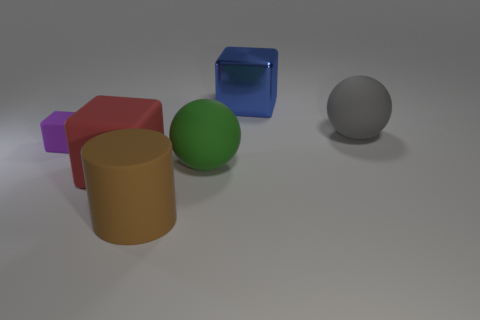Add 1 big matte cubes. How many objects exist? 7 Subtract all spheres. How many objects are left? 4 Subtract all big rubber blocks. Subtract all big green rubber balls. How many objects are left? 4 Add 5 gray things. How many gray things are left? 6 Add 4 big balls. How many big balls exist? 6 Subtract 1 red cubes. How many objects are left? 5 